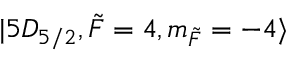<formula> <loc_0><loc_0><loc_500><loc_500>| 5 D _ { 5 / 2 } , \tilde { F } = 4 , m _ { \tilde { F } } = - 4 \rangle</formula> 